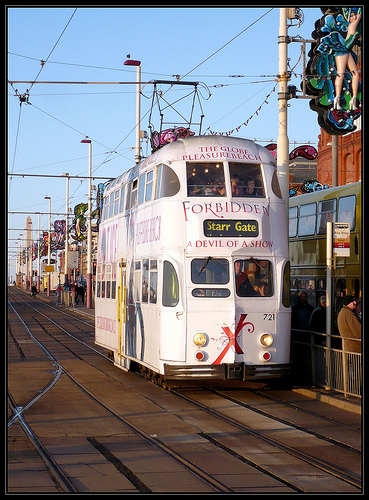<image>
Is there a sky behind the wire? Yes. From this viewpoint, the sky is positioned behind the wire, with the wire partially or fully occluding the sky. 